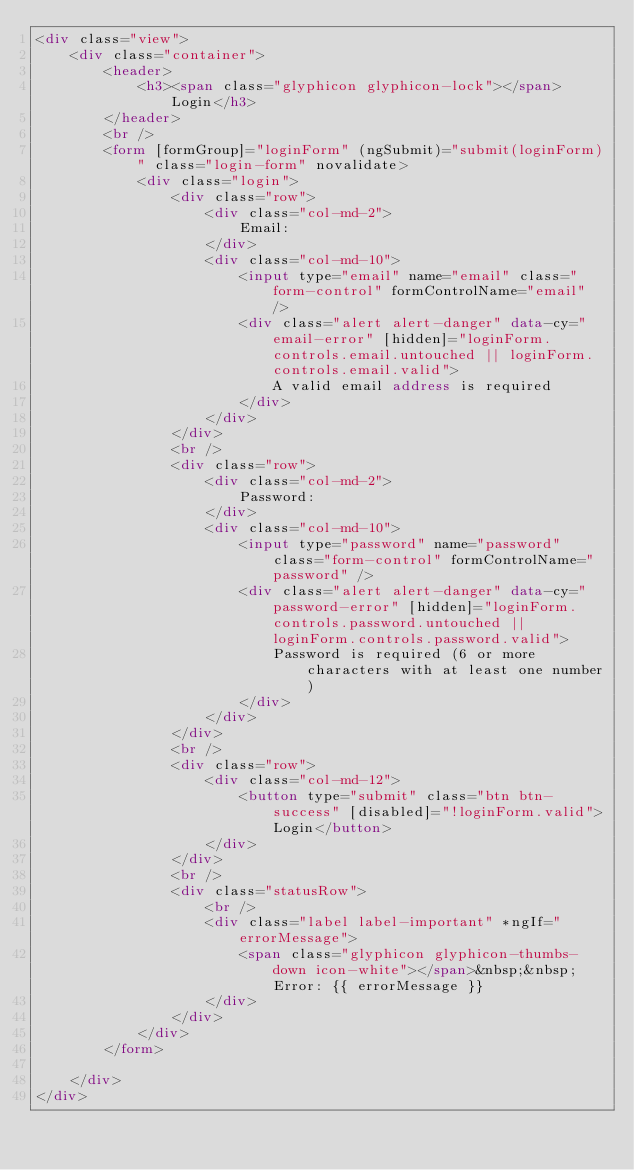Convert code to text. <code><loc_0><loc_0><loc_500><loc_500><_HTML_><div class="view">
    <div class="container">
        <header>
            <h3><span class="glyphicon glyphicon-lock"></span> Login</h3>
        </header>
        <br />
        <form [formGroup]="loginForm" (ngSubmit)="submit(loginForm)" class="login-form" novalidate>
            <div class="login">
                <div class="row">
                    <div class="col-md-2">
                        Email:
                    </div>
                    <div class="col-md-10">
                        <input type="email" name="email" class="form-control" formControlName="email" />
                        <div class="alert alert-danger" data-cy="email-error" [hidden]="loginForm.controls.email.untouched || loginForm.controls.email.valid">
                            A valid email address is required
                        </div>
                    </div>
                </div>
                <br />
                <div class="row">
                    <div class="col-md-2">
                        Password:
                    </div>
                    <div class="col-md-10">
                        <input type="password" name="password" class="form-control" formControlName="password" />
                        <div class="alert alert-danger" data-cy="password-error" [hidden]="loginForm.controls.password.untouched || loginForm.controls.password.valid">
                            Password is required (6 or more characters with at least one number)
                        </div>
                    </div>
                </div>
                <br />
                <div class="row">
                    <div class="col-md-12">
                        <button type="submit" class="btn btn-success" [disabled]="!loginForm.valid">Login</button>
                    </div>
                </div>
                <br />
                <div class="statusRow">
                    <br />
                    <div class="label label-important" *ngIf="errorMessage">
                        <span class="glyphicon glyphicon-thumbs-down icon-white"></span>&nbsp;&nbsp;Error: {{ errorMessage }}
                    </div>
                </div>
            </div>
        </form>
        
    </div>
</div></code> 